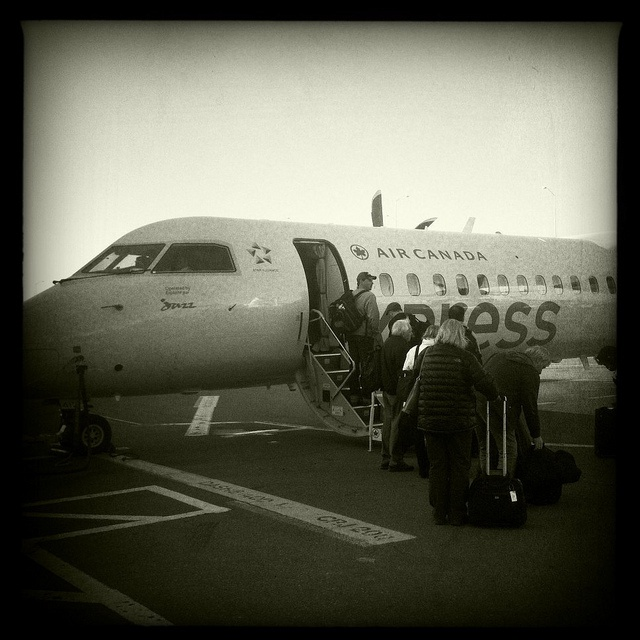Describe the objects in this image and their specific colors. I can see airplane in black, gray, darkgray, and darkgreen tones, people in black, gray, and darkgreen tones, people in black, gray, darkgreen, and darkgray tones, handbag in black, gray, darkgreen, and darkgray tones, and people in black, gray, darkgray, and darkgreen tones in this image. 